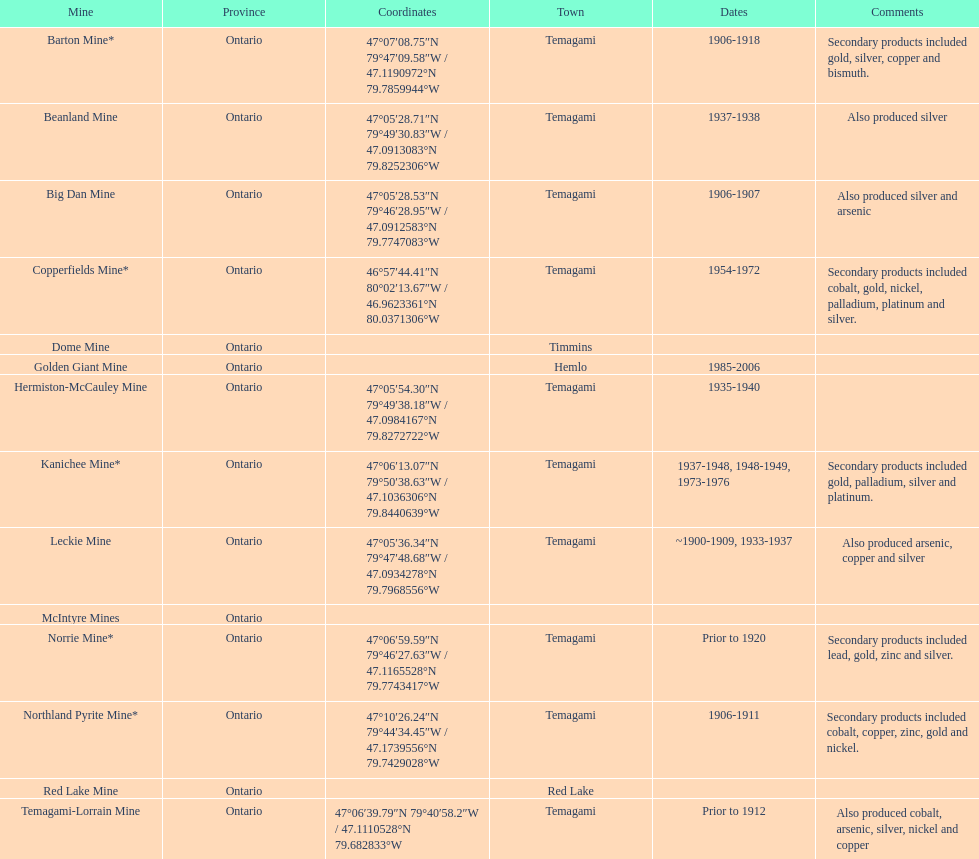In what mine could you find bismuth? Barton Mine. 